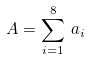<formula> <loc_0><loc_0><loc_500><loc_500>A = \sum _ { i = 1 } ^ { 8 } \, a _ { i }</formula> 